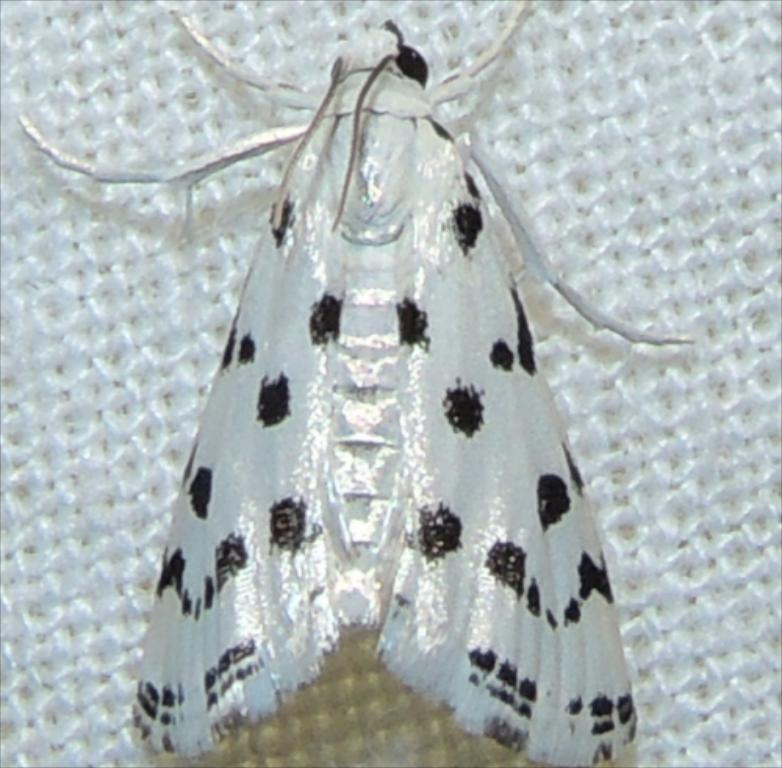What type of creature is in the picture? There is an insect in the picture. Can you describe the color pattern of the insect? The insect has a white and black color pattern. What is the background or surface that the insect is on? The insect is on a white surface. What type of owl can be seen in the picture? There is no owl present in the picture; it features an insect with a white and black color pattern on a white surface. How many brothers are visible in the picture? There are no brothers present in the picture; it features an insect on a white surface. 